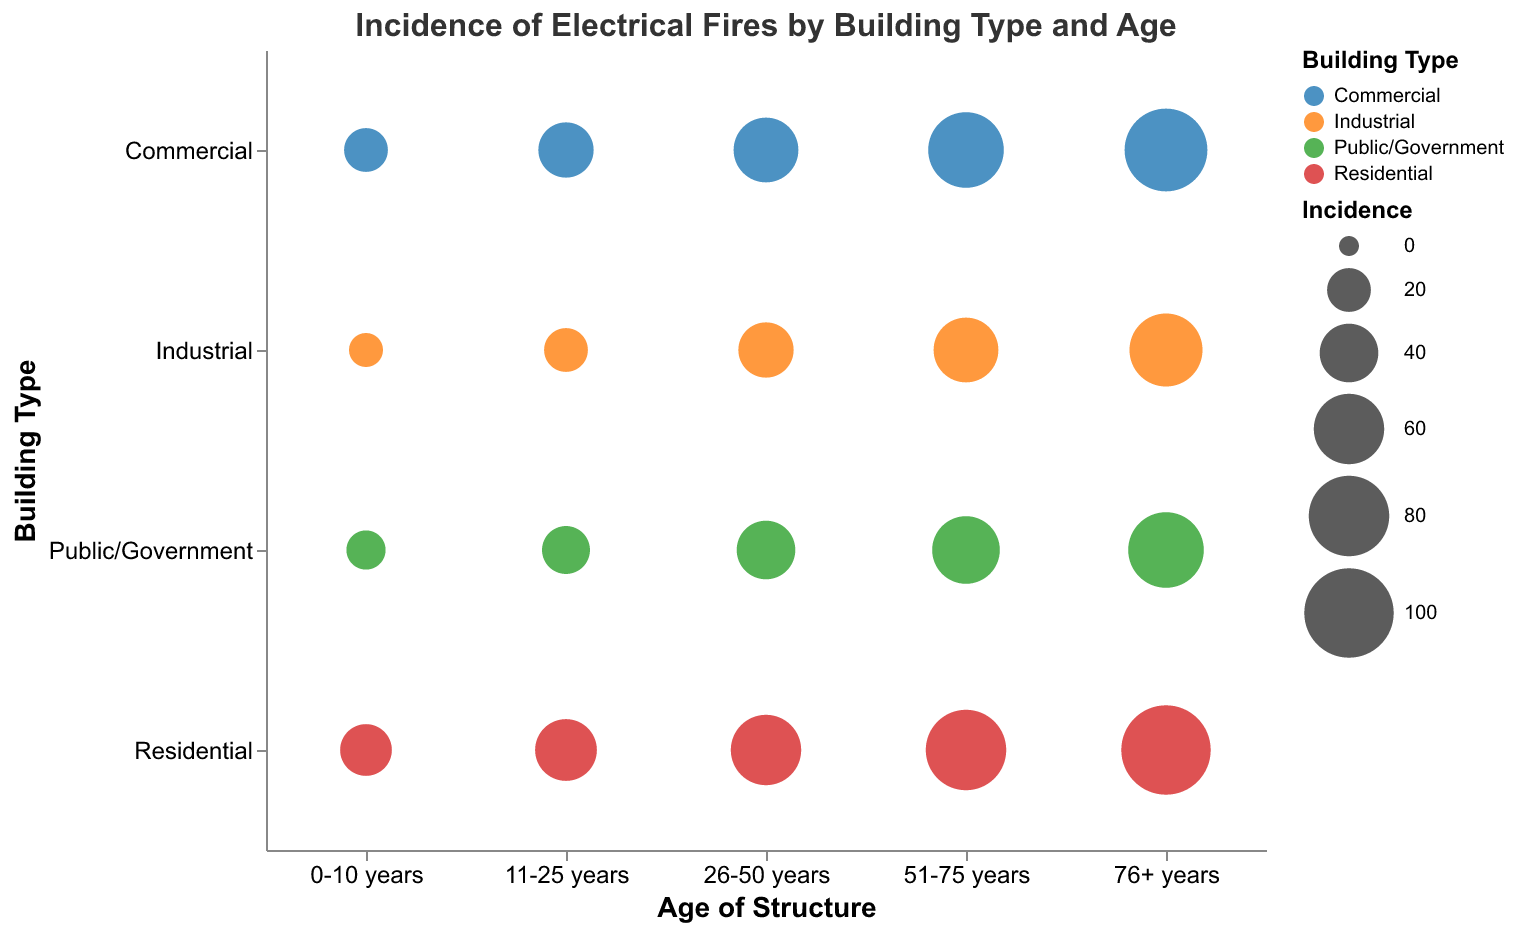What's the title of the figure? The title of the figure is clearly stated at the top of the chart. It is "Incidence of Electrical Fires by Building Type and Age."
Answer: Incidence of Electrical Fires by Building Type and Age How many building types are represented in the chart? By looking at the y-axis of the chart, we can see four distinct categories, which are the building types. The building types listed are Residential, Commercial, Industrial, and Public/Government.
Answer: 4 Which building type has the highest incidence of electrical fires in the 76+ years age group? Observing the size of the bubbles at the intersection of the 76+ years age group and each building type on the y-axis, the largest bubble corresponds to Residential buildings.
Answer: Residential How does the incidence of electrical fires in Industrial buildings aged 0-10 years compare to those aged 26-50 years? By comparing the size of the bubbles at the intersection of the Industrial building type with the 0-10 years and 26-50 years age groups, we can see that the incidence increases as the building ages. The bubble for the 0-10 years group is smaller (10) than the 26-50 years group (35).
Answer: Incidence increases Which age group for Commercial buildings has the highest incidence of electrical fires? Observing the bubbles on the chart corresponding to Commercial buildings, the largest bubble for this type is found in the 76+ years age group, indicating the highest incidence.
Answer: 76+ years What is the total incidence of electrical fires in Public/Government buildings considering all age groups? Sum the incidence values across all age groups for Public/Government buildings (15 + 25 + 40 + 55 + 70). The sum is 205, representing the total incidence.
Answer: 205 What trend do you observe about the incidence of electrical fires in Residential buildings as they age? By looking at the bubbles for Residential buildings from 0-10 years to 76+ years, the bubbles progressively increase in size, indicating a growing incidence as the buildings age.
Answer: Incidence increases with age In which age group do Public/Government buildings have a similar incidence to Industrial buildings aged 76+ years? By comparing the incidence values, Public/Government buildings in the 76+ years age group have an incidence of 70, which is similar to Industrial buildings aged 76+ years, having an incidence of 65.
Answer: 76+ years Which building type has the smallest incidence of electrical fires in the 0-10 years age group? By comparing the size of bubbles in the 0-10 years age group, the smallest bubble belongs to Industrial buildings, indicating the smallest incidence.
Answer: Industrial 